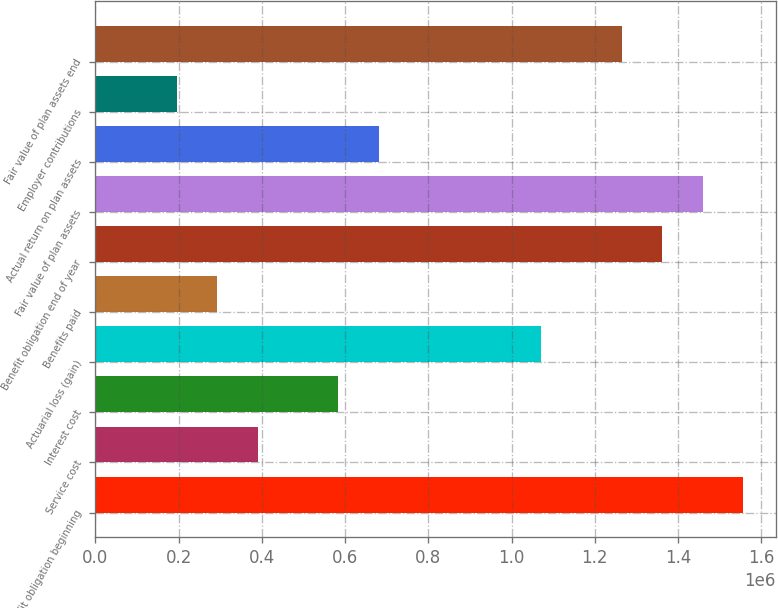<chart> <loc_0><loc_0><loc_500><loc_500><bar_chart><fcel>Benefit obligation beginning<fcel>Service cost<fcel>Interest cost<fcel>Actuarial loss (gain)<fcel>Benefits paid<fcel>Benefit obligation end of year<fcel>Fair value of plan assets<fcel>Actual return on plan assets<fcel>Employer contributions<fcel>Fair value of plan assets end<nl><fcel>1.5566e+06<fcel>389458<fcel>583982<fcel>1.07029e+06<fcel>292196<fcel>1.36208e+06<fcel>1.45934e+06<fcel>681244<fcel>194933<fcel>1.26482e+06<nl></chart> 